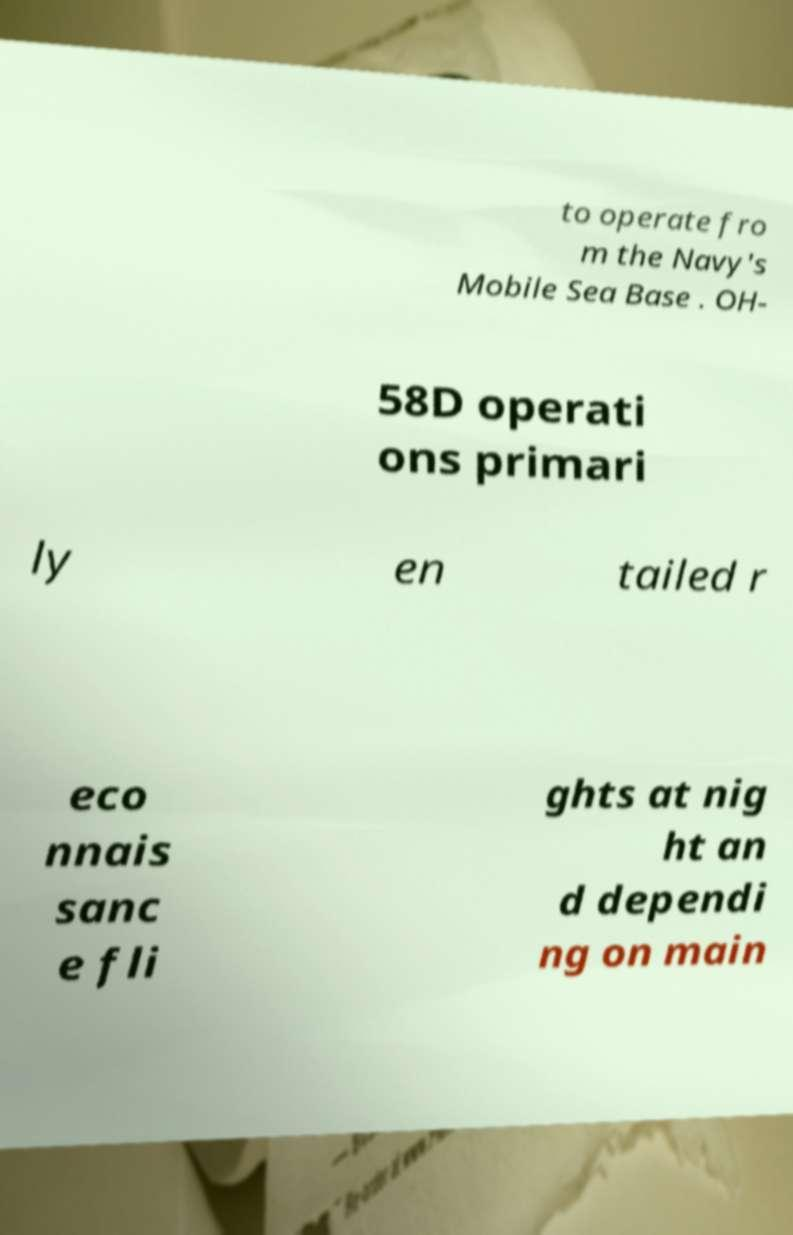Could you extract and type out the text from this image? to operate fro m the Navy's Mobile Sea Base . OH- 58D operati ons primari ly en tailed r eco nnais sanc e fli ghts at nig ht an d dependi ng on main 